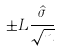Convert formula to latex. <formula><loc_0><loc_0><loc_500><loc_500>\pm L \frac { \hat { \sigma } } { \sqrt { n } }</formula> 